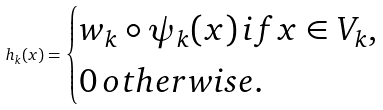Convert formula to latex. <formula><loc_0><loc_0><loc_500><loc_500>h _ { k } ( x ) = \begin{cases} w _ { k } \circ \psi _ { k } ( x ) \, i f x \in V _ { k } , \\ 0 \, o t h e r w i s e . \end{cases}</formula> 